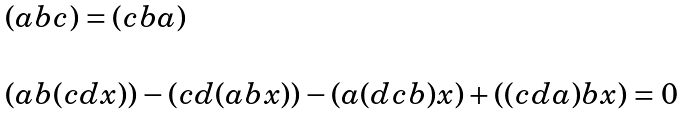<formula> <loc_0><loc_0><loc_500><loc_500>\begin{array} { l } ( a b c ) = ( c b a ) \\ \ \\ ( a b ( c d x ) ) - ( c d ( a b x ) ) - ( a ( d c b ) x ) + ( ( c d a ) b x ) = 0 \end{array}</formula> 